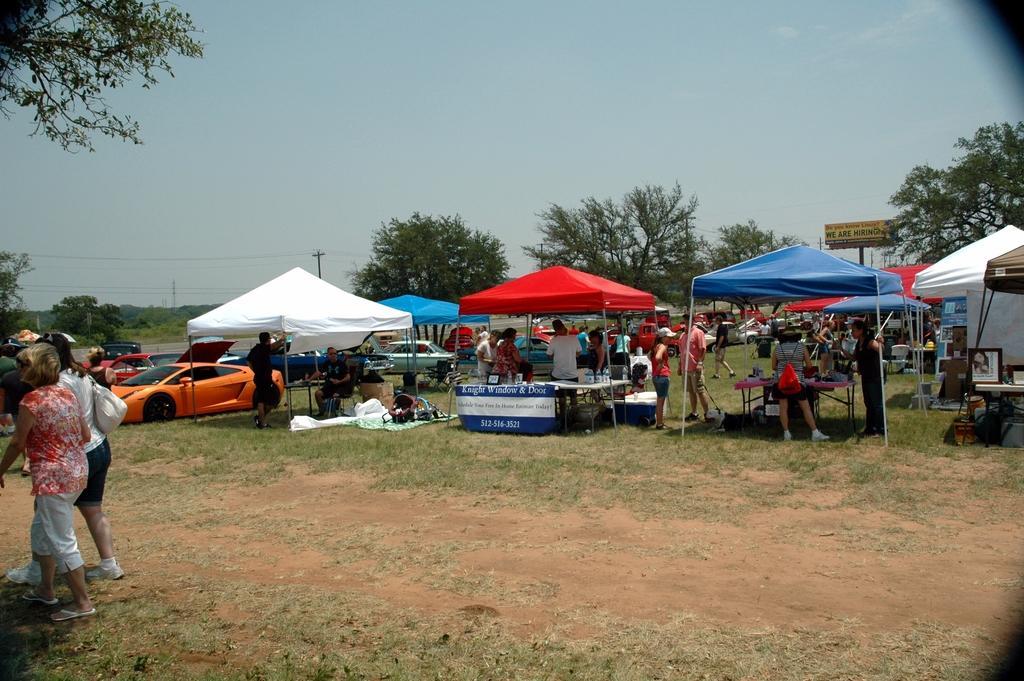How would you summarize this image in a sentence or two? In the foreground of the pictures of plant, soil and grass. On the left there are people, plants and trees. In the center of the picture there are canopies, people and cars. In the background there are trees and sky and there are pole, hoarding. 